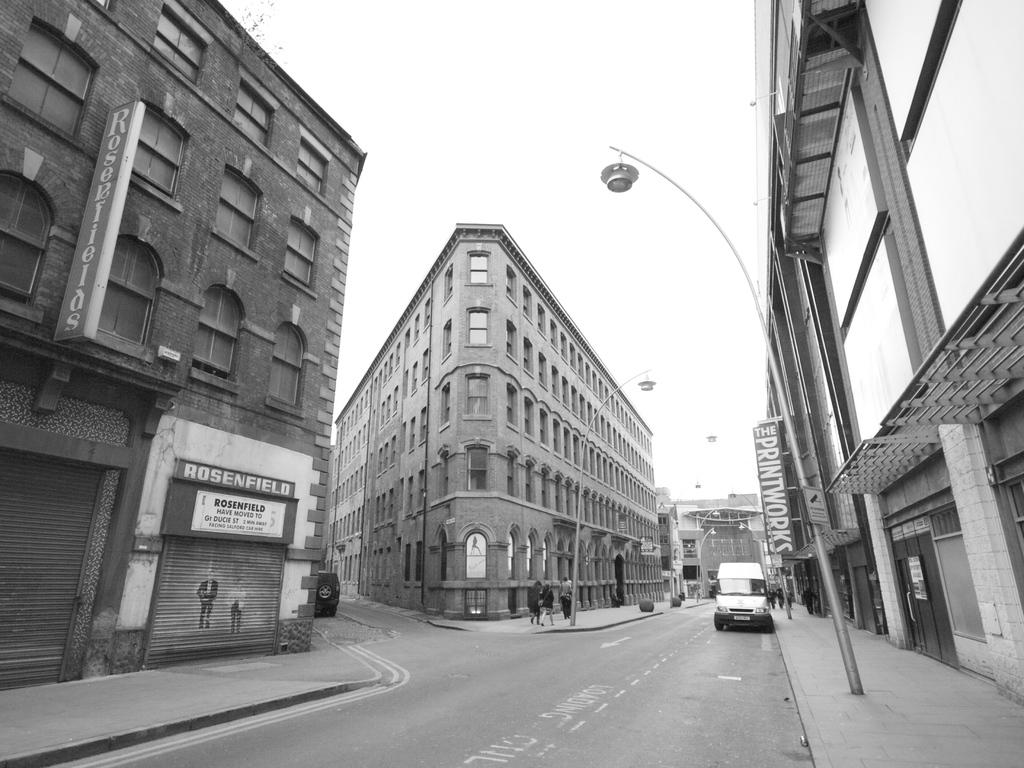<image>
Render a clear and concise summary of the photo. A shop called Rosenfield is located on Ducie St 